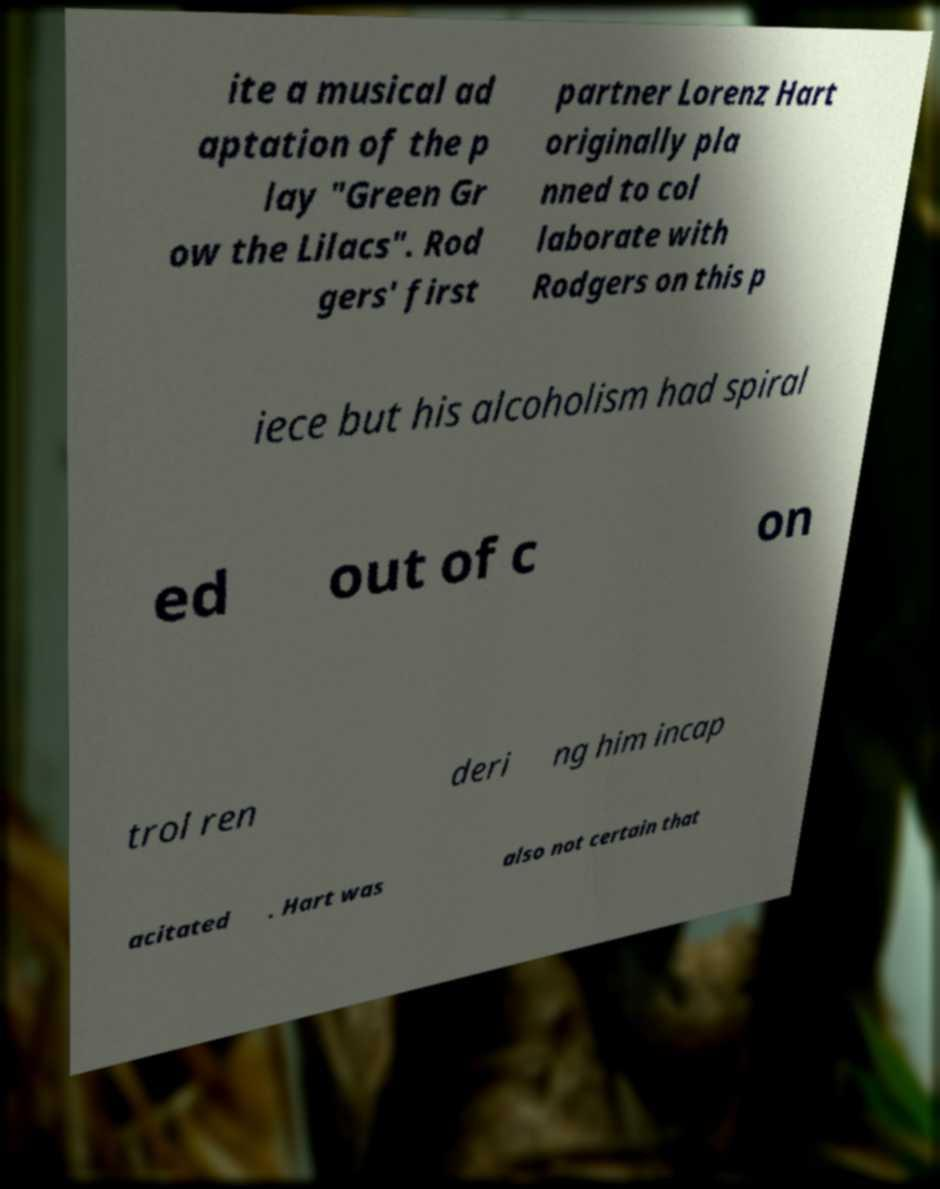For documentation purposes, I need the text within this image transcribed. Could you provide that? ite a musical ad aptation of the p lay "Green Gr ow the Lilacs". Rod gers' first partner Lorenz Hart originally pla nned to col laborate with Rodgers on this p iece but his alcoholism had spiral ed out of c on trol ren deri ng him incap acitated . Hart was also not certain that 